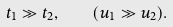<formula> <loc_0><loc_0><loc_500><loc_500>t _ { 1 } \gg t _ { 2 } , \quad ( u _ { 1 } \gg u _ { 2 } ) .</formula> 